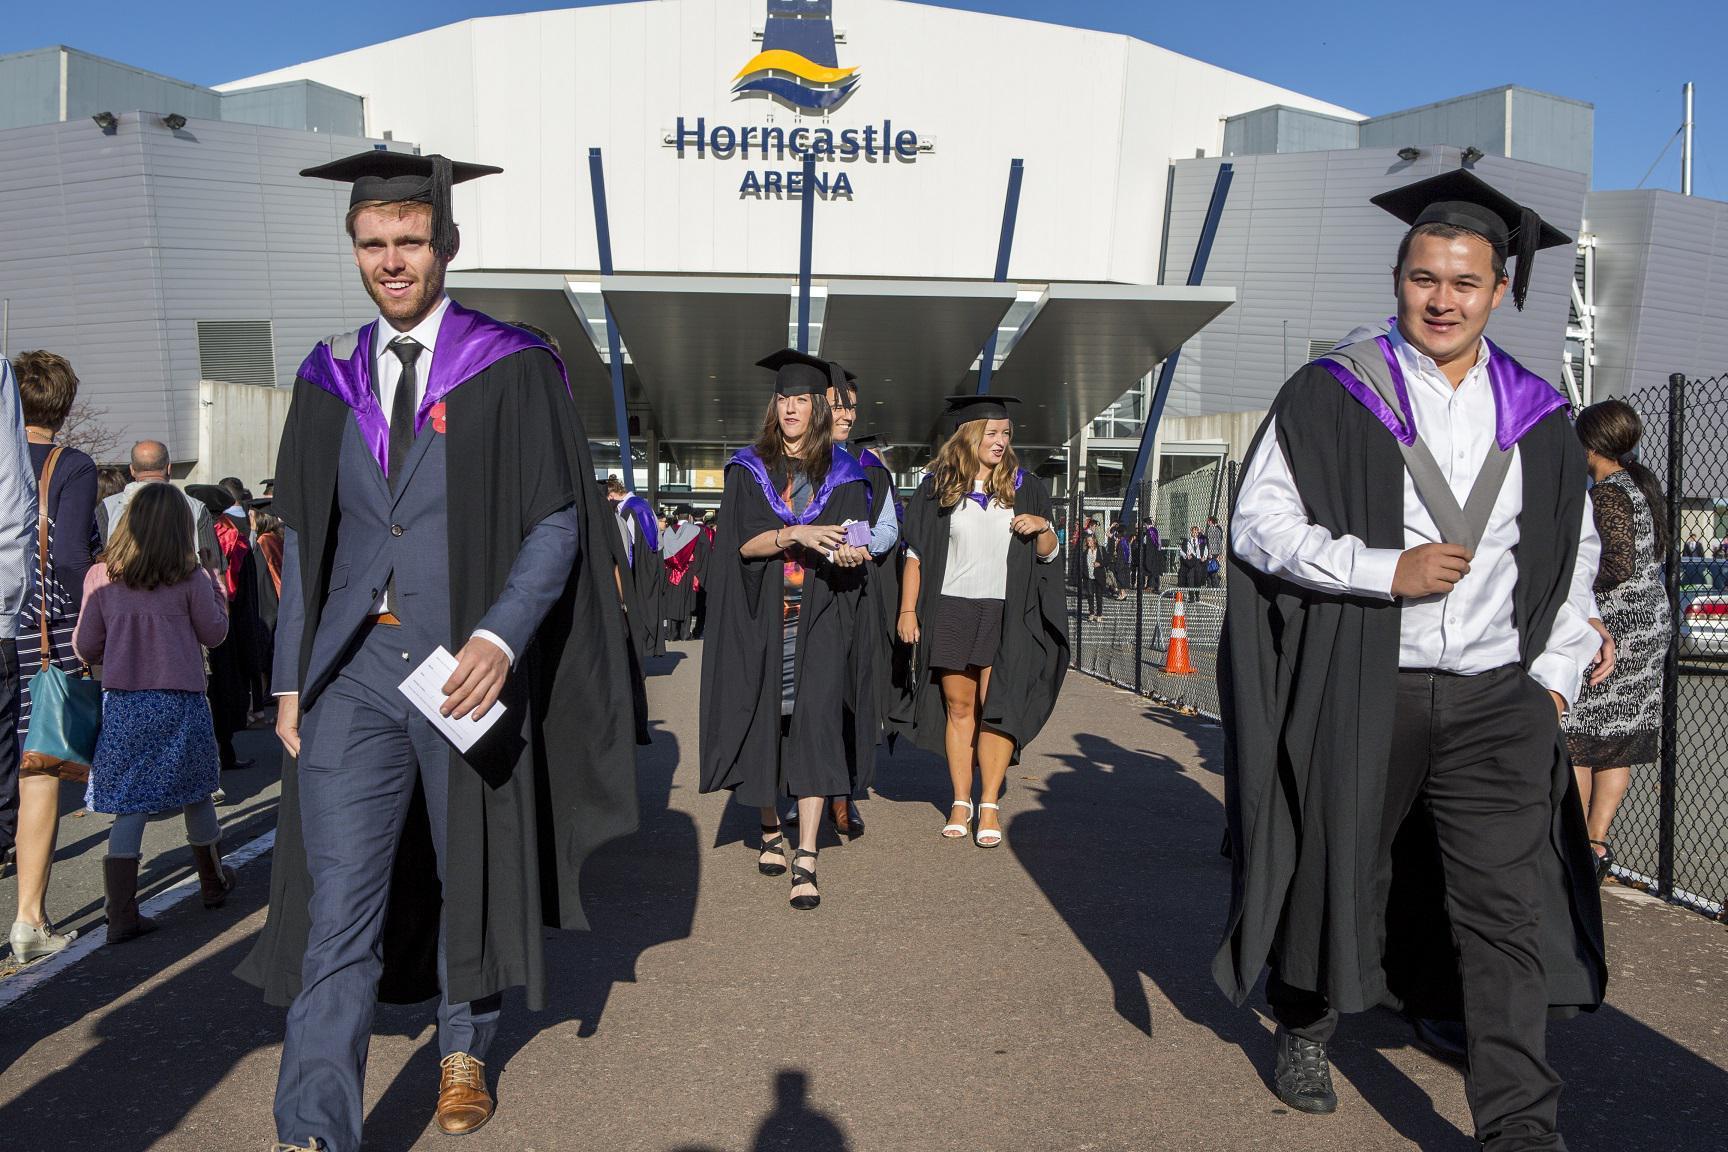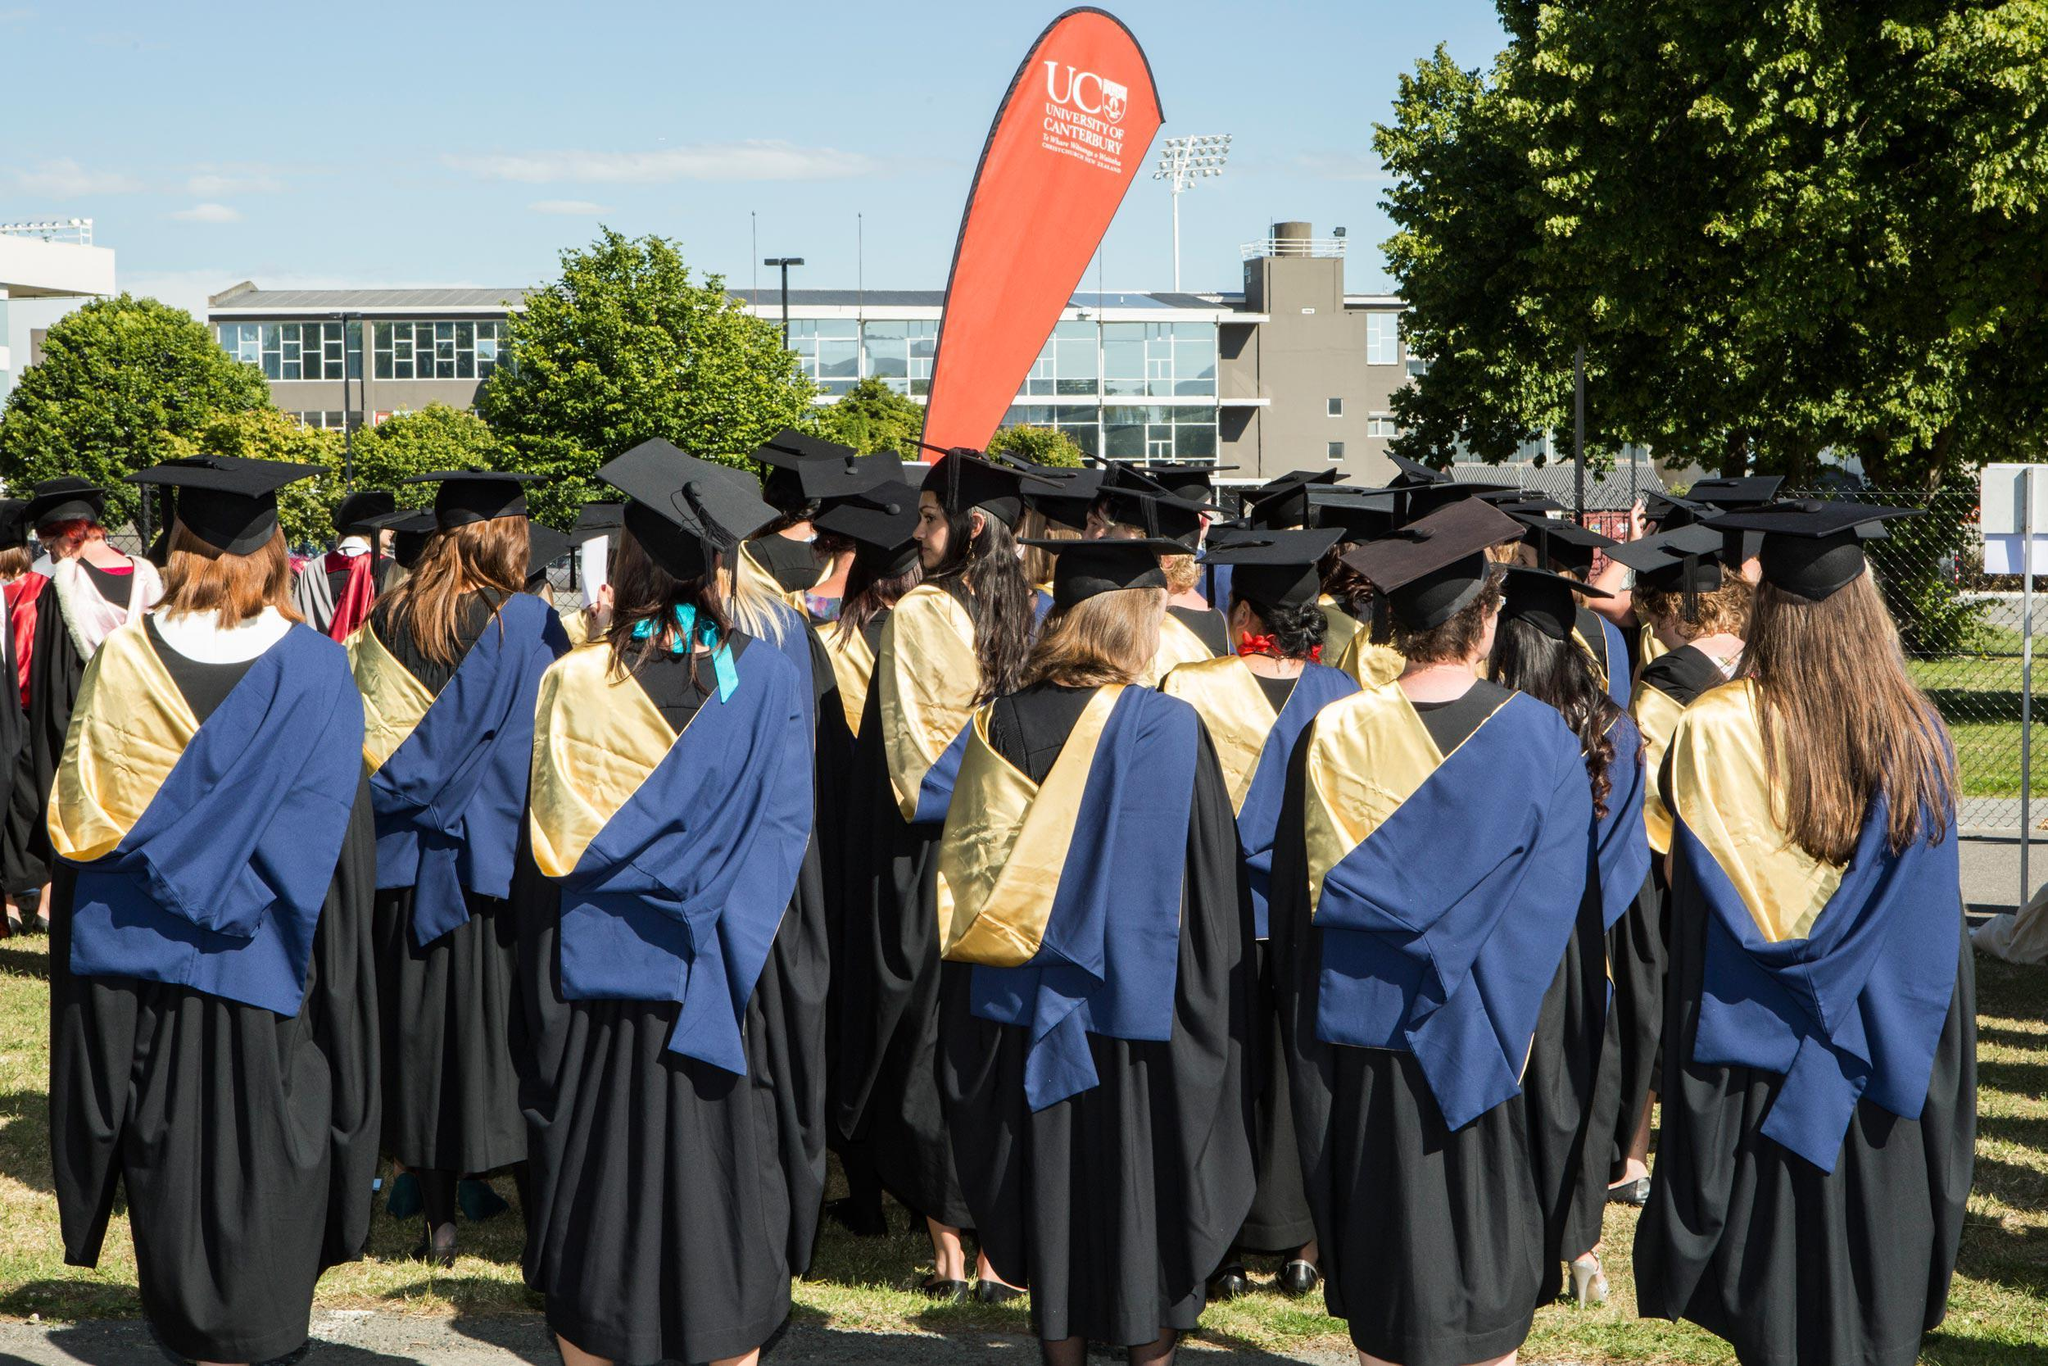The first image is the image on the left, the second image is the image on the right. Examine the images to the left and right. Is the description "Everyone in the image on the right is wearing a red stole." accurate? Answer yes or no. No. The first image is the image on the left, the second image is the image on the right. For the images shown, is this caption "At least one image includes multiple people wearing red sashes and a non-traditional graduation black cap." true? Answer yes or no. No. 